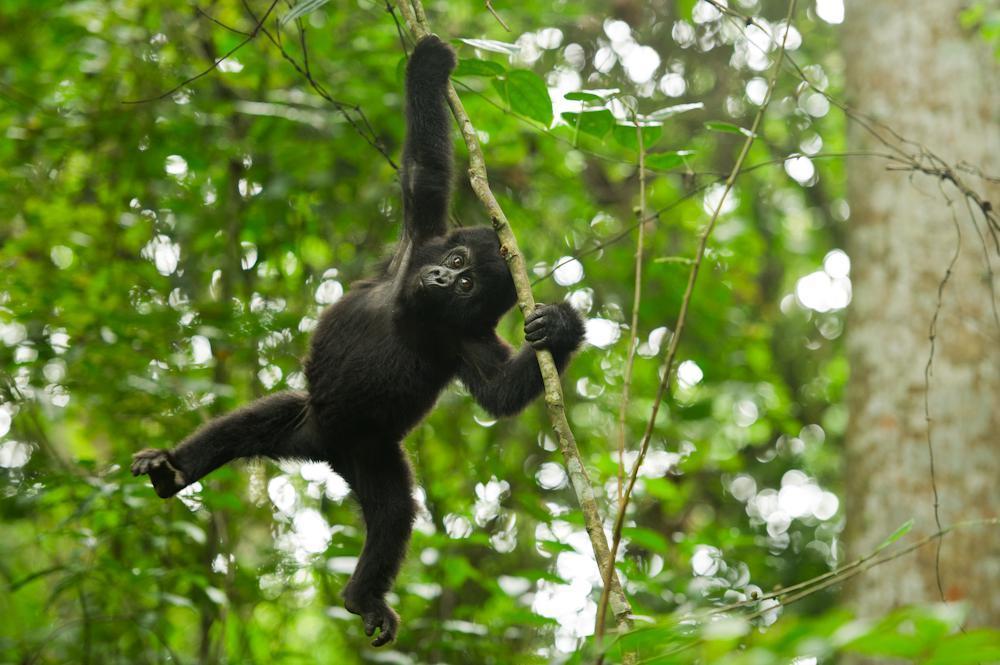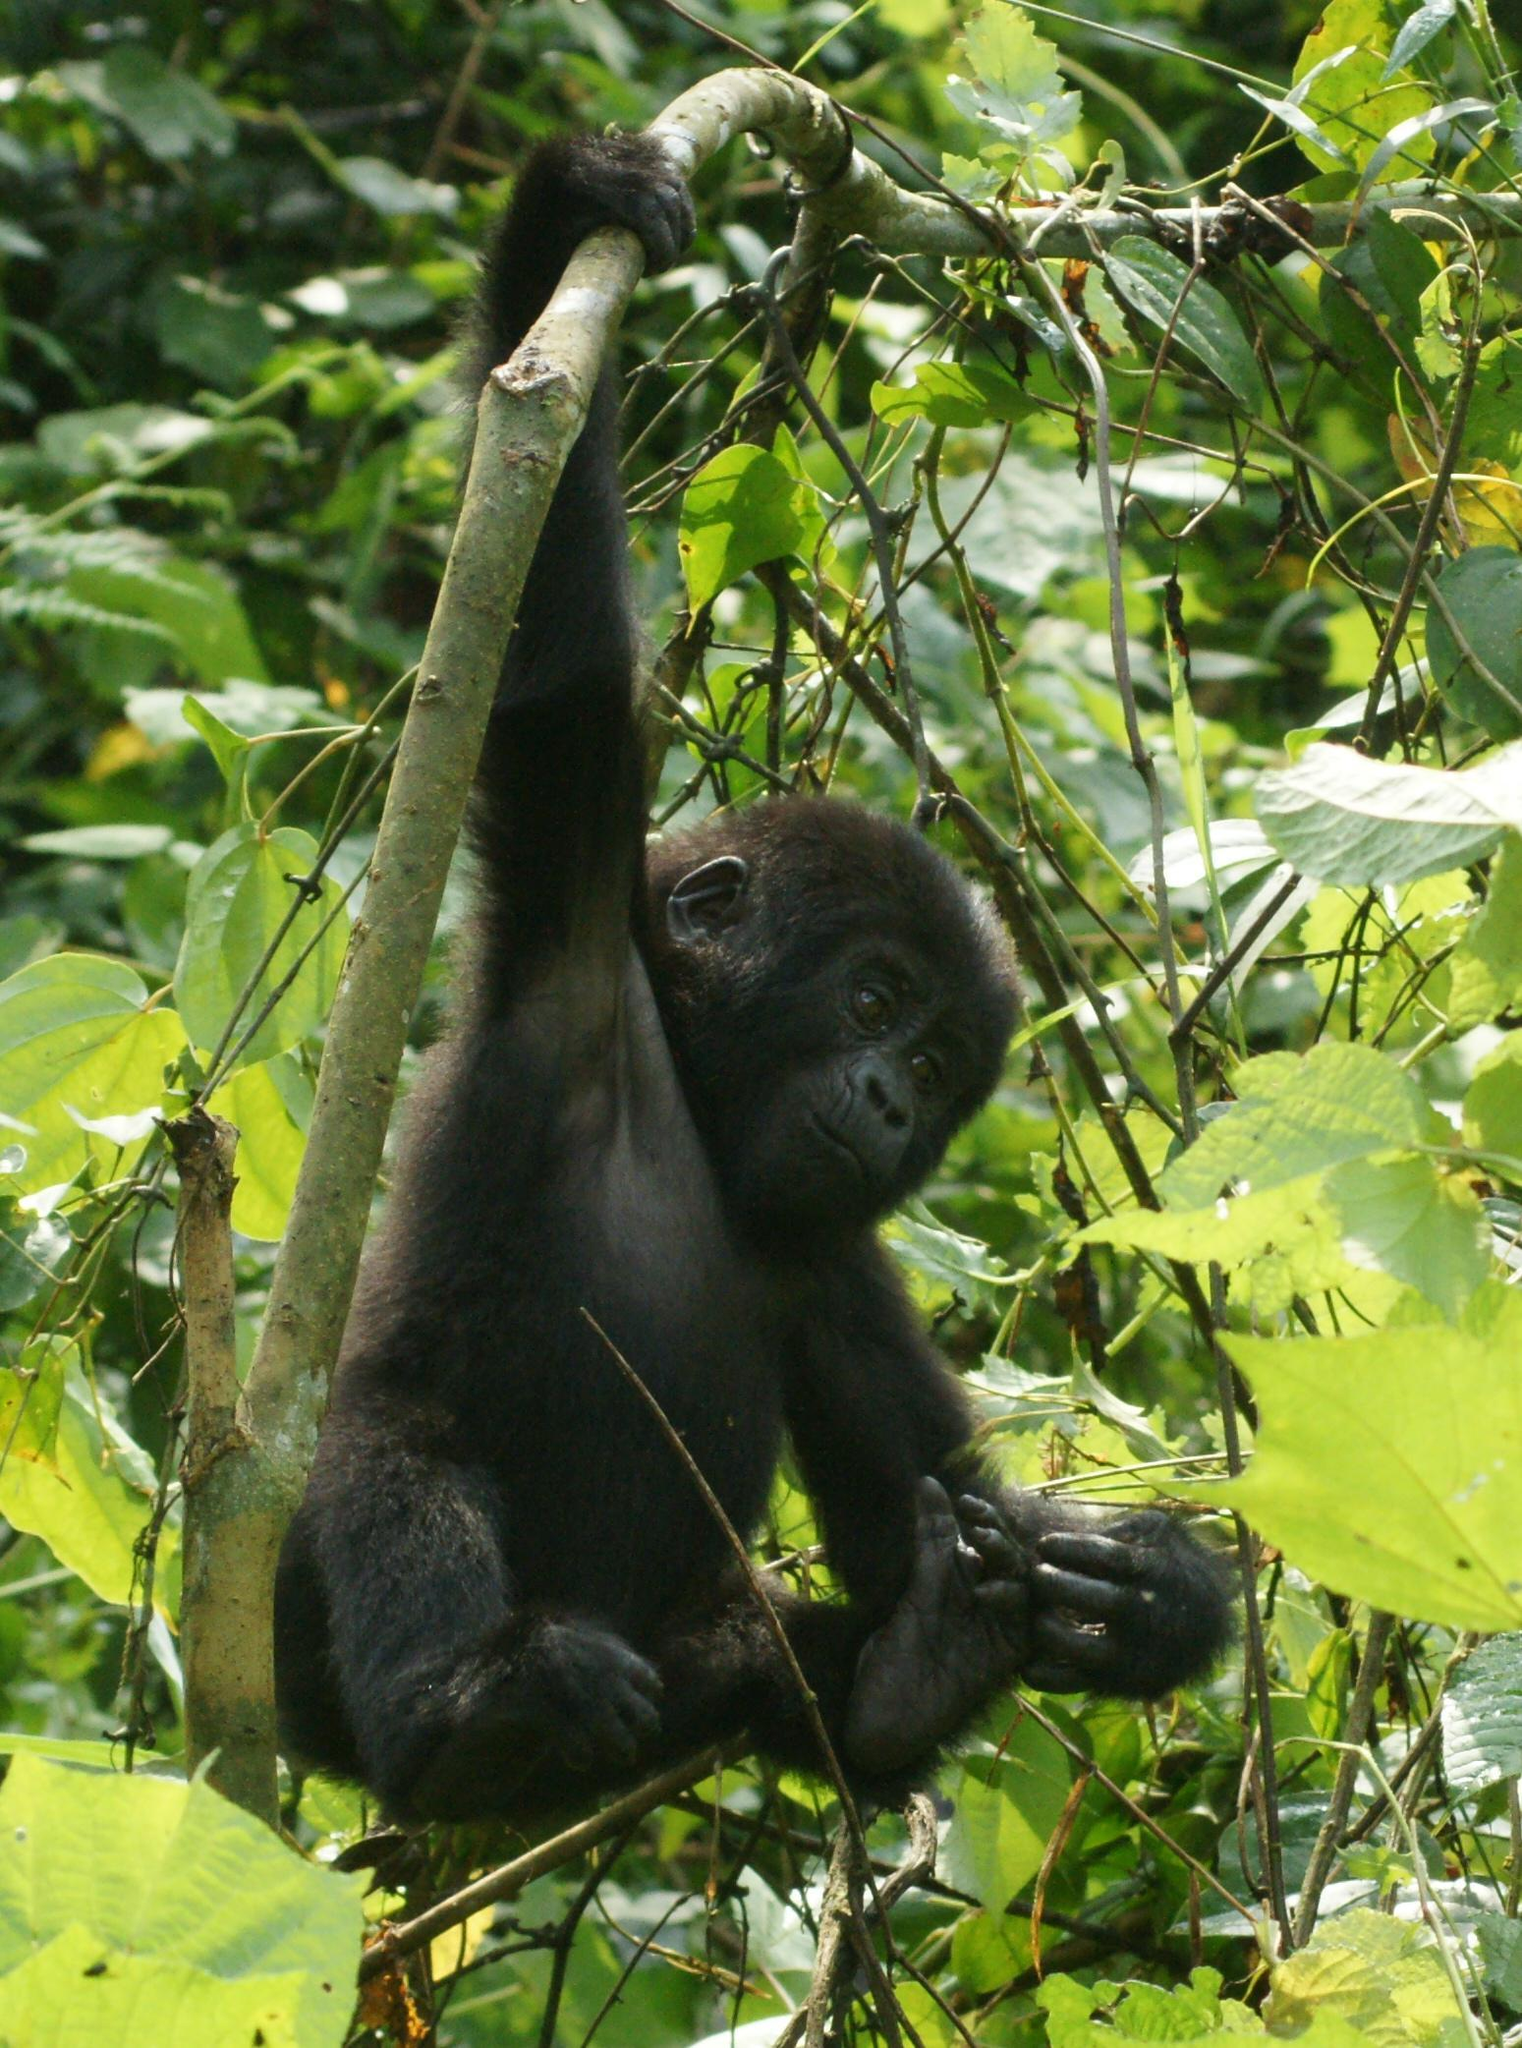The first image is the image on the left, the second image is the image on the right. Given the left and right images, does the statement "Each image contains just one ape, and each ape is hanging from a branch-like growth." hold true? Answer yes or no. Yes. The first image is the image on the left, the second image is the image on the right. For the images displayed, is the sentence "At least one ape is on the ground." factually correct? Answer yes or no. No. 